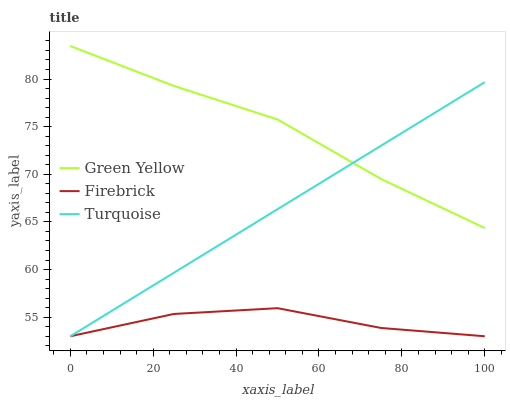Does Firebrick have the minimum area under the curve?
Answer yes or no. Yes. Does Green Yellow have the maximum area under the curve?
Answer yes or no. Yes. Does Turquoise have the minimum area under the curve?
Answer yes or no. No. Does Turquoise have the maximum area under the curve?
Answer yes or no. No. Is Turquoise the smoothest?
Answer yes or no. Yes. Is Firebrick the roughest?
Answer yes or no. Yes. Is Green Yellow the smoothest?
Answer yes or no. No. Is Green Yellow the roughest?
Answer yes or no. No. Does Firebrick have the lowest value?
Answer yes or no. Yes. Does Green Yellow have the lowest value?
Answer yes or no. No. Does Green Yellow have the highest value?
Answer yes or no. Yes. Does Turquoise have the highest value?
Answer yes or no. No. Is Firebrick less than Green Yellow?
Answer yes or no. Yes. Is Green Yellow greater than Firebrick?
Answer yes or no. Yes. Does Green Yellow intersect Turquoise?
Answer yes or no. Yes. Is Green Yellow less than Turquoise?
Answer yes or no. No. Is Green Yellow greater than Turquoise?
Answer yes or no. No. Does Firebrick intersect Green Yellow?
Answer yes or no. No. 